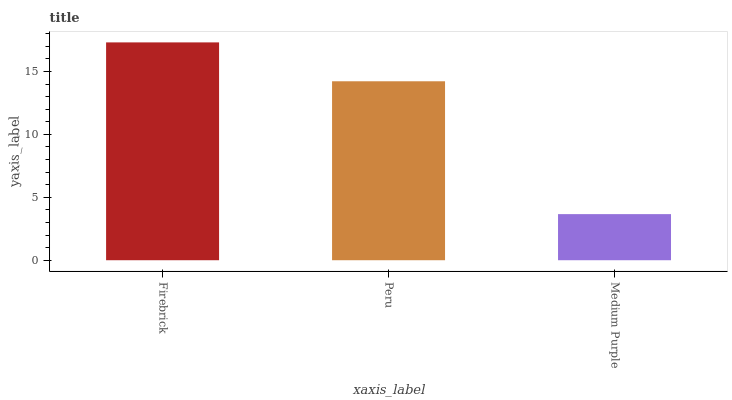Is Medium Purple the minimum?
Answer yes or no. Yes. Is Firebrick the maximum?
Answer yes or no. Yes. Is Peru the minimum?
Answer yes or no. No. Is Peru the maximum?
Answer yes or no. No. Is Firebrick greater than Peru?
Answer yes or no. Yes. Is Peru less than Firebrick?
Answer yes or no. Yes. Is Peru greater than Firebrick?
Answer yes or no. No. Is Firebrick less than Peru?
Answer yes or no. No. Is Peru the high median?
Answer yes or no. Yes. Is Peru the low median?
Answer yes or no. Yes. Is Firebrick the high median?
Answer yes or no. No. Is Medium Purple the low median?
Answer yes or no. No. 